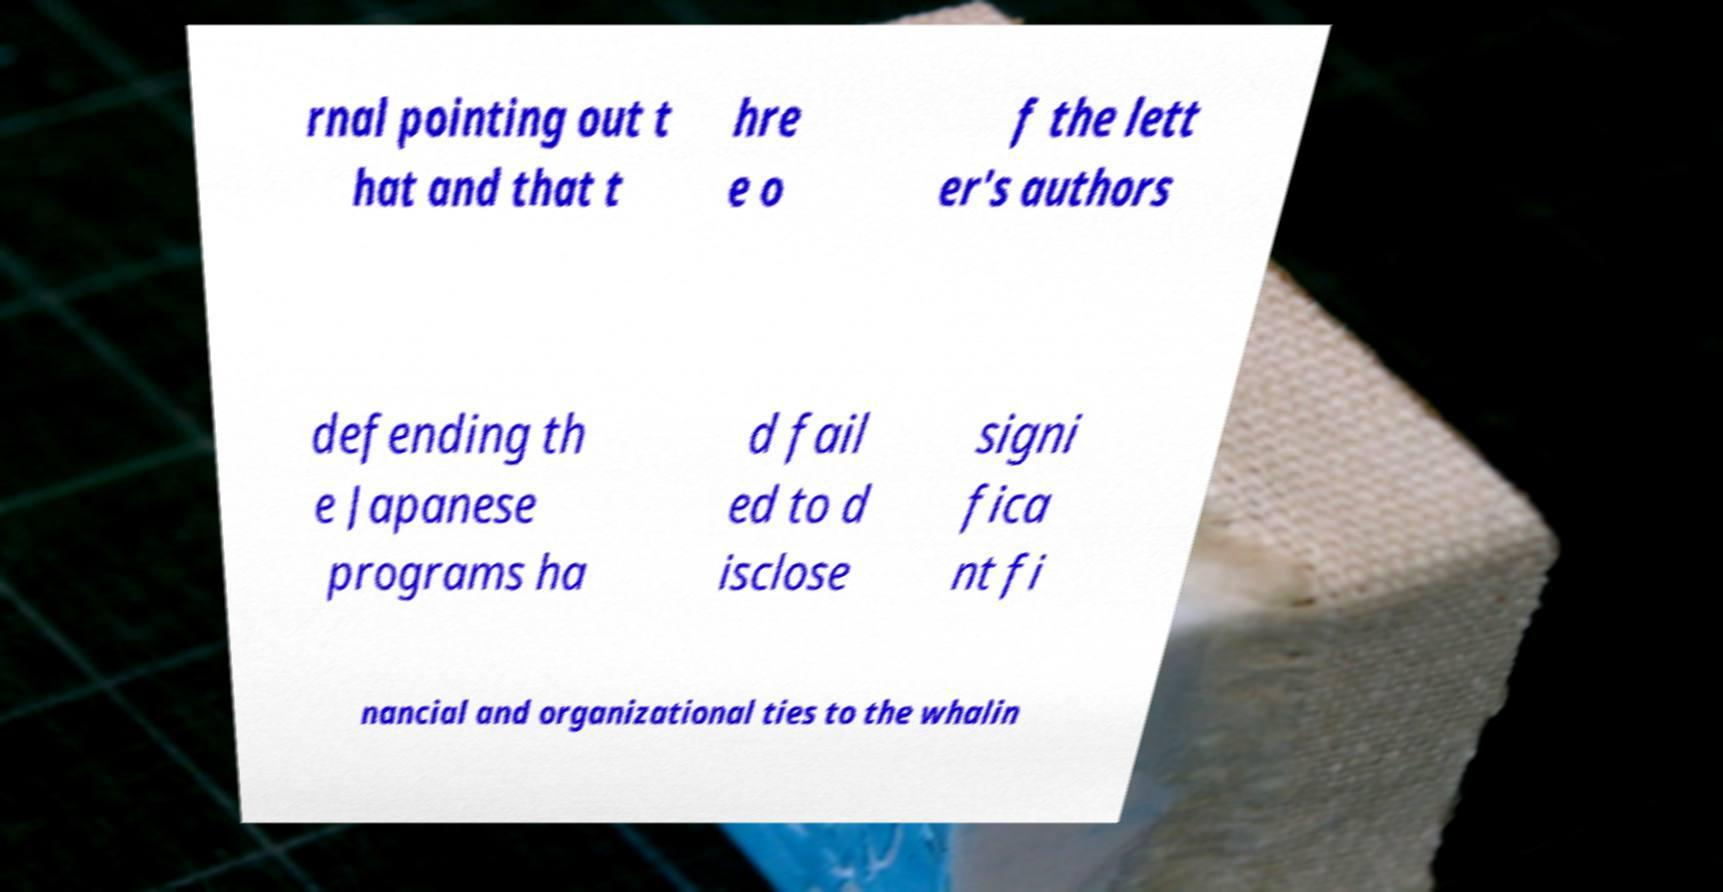Please identify and transcribe the text found in this image. rnal pointing out t hat and that t hre e o f the lett er's authors defending th e Japanese programs ha d fail ed to d isclose signi fica nt fi nancial and organizational ties to the whalin 